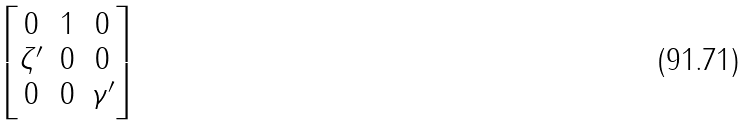<formula> <loc_0><loc_0><loc_500><loc_500>\begin{bmatrix} 0 & 1 & 0 \\ \zeta ^ { \prime } & 0 & 0 \\ 0 & 0 & \gamma ^ { \prime } \\ \end{bmatrix}</formula> 